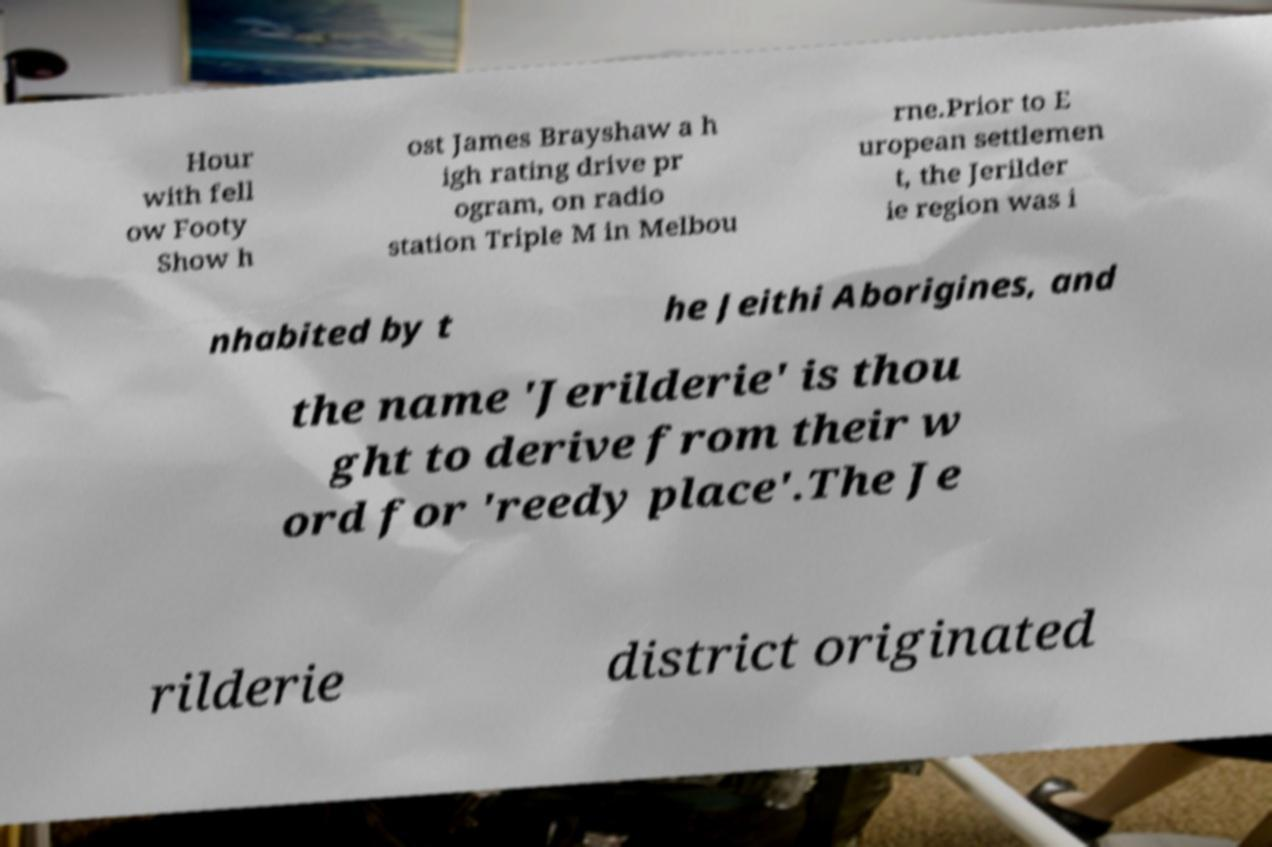Please identify and transcribe the text found in this image. Hour with fell ow Footy Show h ost James Brayshaw a h igh rating drive pr ogram, on radio station Triple M in Melbou rne.Prior to E uropean settlemen t, the Jerilder ie region was i nhabited by t he Jeithi Aborigines, and the name 'Jerilderie' is thou ght to derive from their w ord for 'reedy place'.The Je rilderie district originated 